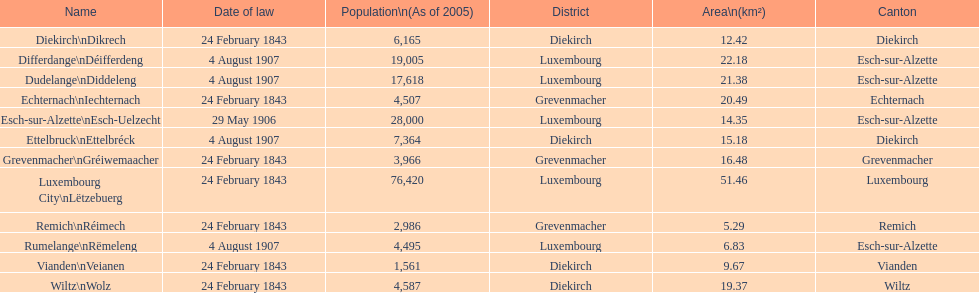What canton is the most populated? Luxembourg. 